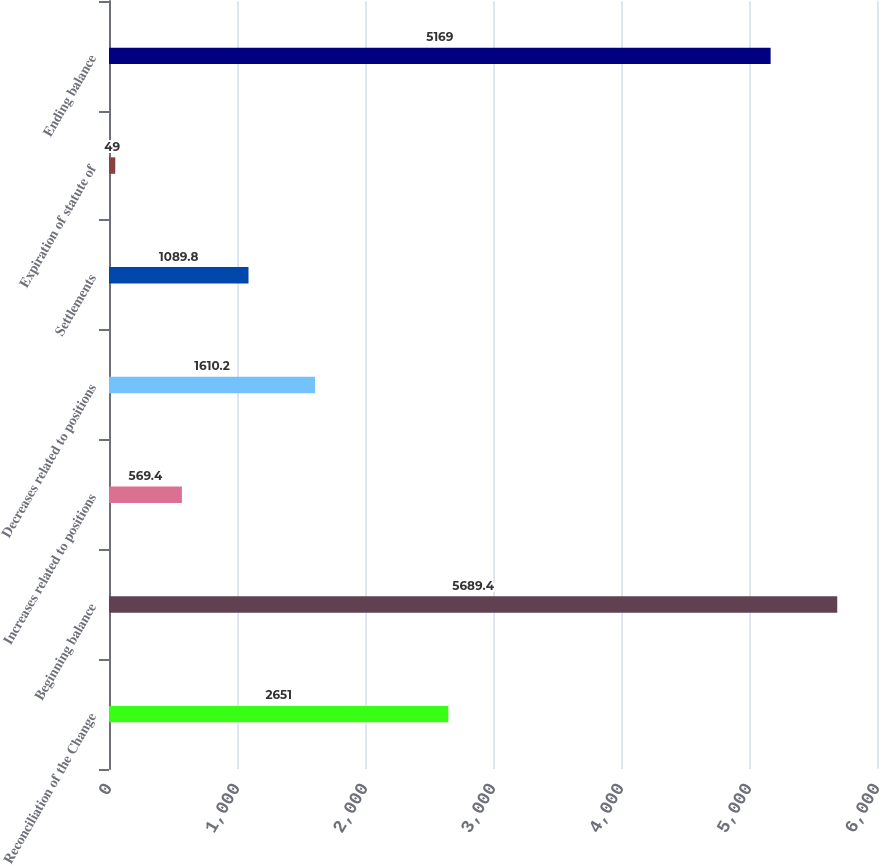Convert chart. <chart><loc_0><loc_0><loc_500><loc_500><bar_chart><fcel>Reconciliation of the Change<fcel>Beginning balance<fcel>Increases related to positions<fcel>Decreases related to positions<fcel>Settlements<fcel>Expiration of statute of<fcel>Ending balance<nl><fcel>2651<fcel>5689.4<fcel>569.4<fcel>1610.2<fcel>1089.8<fcel>49<fcel>5169<nl></chart> 